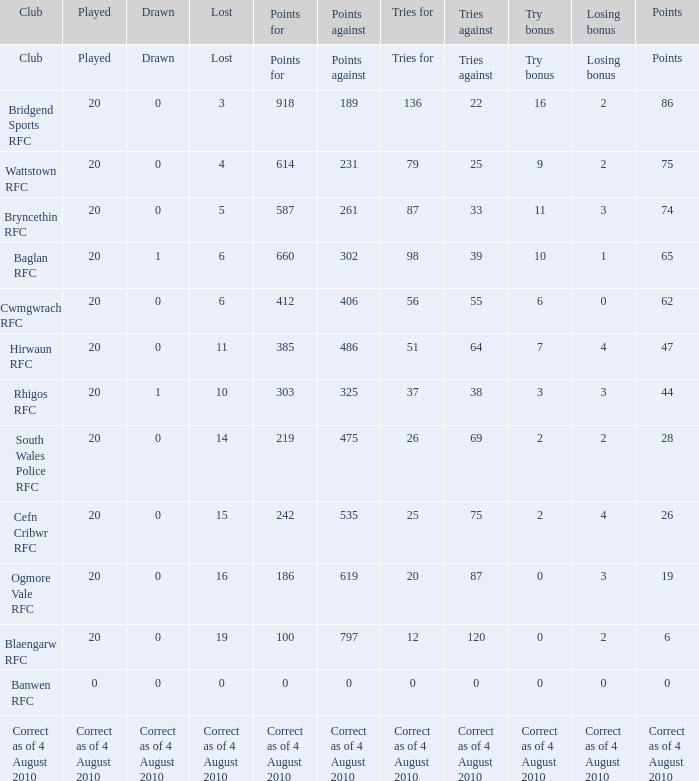What are the counterarguments when a draw is declared? Points against. Parse the table in full. {'header': ['Club', 'Played', 'Drawn', 'Lost', 'Points for', 'Points against', 'Tries for', 'Tries against', 'Try bonus', 'Losing bonus', 'Points'], 'rows': [['Club', 'Played', 'Drawn', 'Lost', 'Points for', 'Points against', 'Tries for', 'Tries against', 'Try bonus', 'Losing bonus', 'Points'], ['Bridgend Sports RFC', '20', '0', '3', '918', '189', '136', '22', '16', '2', '86'], ['Wattstown RFC', '20', '0', '4', '614', '231', '79', '25', '9', '2', '75'], ['Bryncethin RFC', '20', '0', '5', '587', '261', '87', '33', '11', '3', '74'], ['Baglan RFC', '20', '1', '6', '660', '302', '98', '39', '10', '1', '65'], ['Cwmgwrach RFC', '20', '0', '6', '412', '406', '56', '55', '6', '0', '62'], ['Hirwaun RFC', '20', '0', '11', '385', '486', '51', '64', '7', '4', '47'], ['Rhigos RFC', '20', '1', '10', '303', '325', '37', '38', '3', '3', '44'], ['South Wales Police RFC', '20', '0', '14', '219', '475', '26', '69', '2', '2', '28'], ['Cefn Cribwr RFC', '20', '0', '15', '242', '535', '25', '75', '2', '4', '26'], ['Ogmore Vale RFC', '20', '0', '16', '186', '619', '20', '87', '0', '3', '19'], ['Blaengarw RFC', '20', '0', '19', '100', '797', '12', '120', '0', '2', '6'], ['Banwen RFC', '0', '0', '0', '0', '0', '0', '0', '0', '0', '0'], ['Correct as of 4 August 2010', 'Correct as of 4 August 2010', 'Correct as of 4 August 2010', 'Correct as of 4 August 2010', 'Correct as of 4 August 2010', 'Correct as of 4 August 2010', 'Correct as of 4 August 2010', 'Correct as of 4 August 2010', 'Correct as of 4 August 2010', 'Correct as of 4 August 2010', 'Correct as of 4 August 2010']]} 